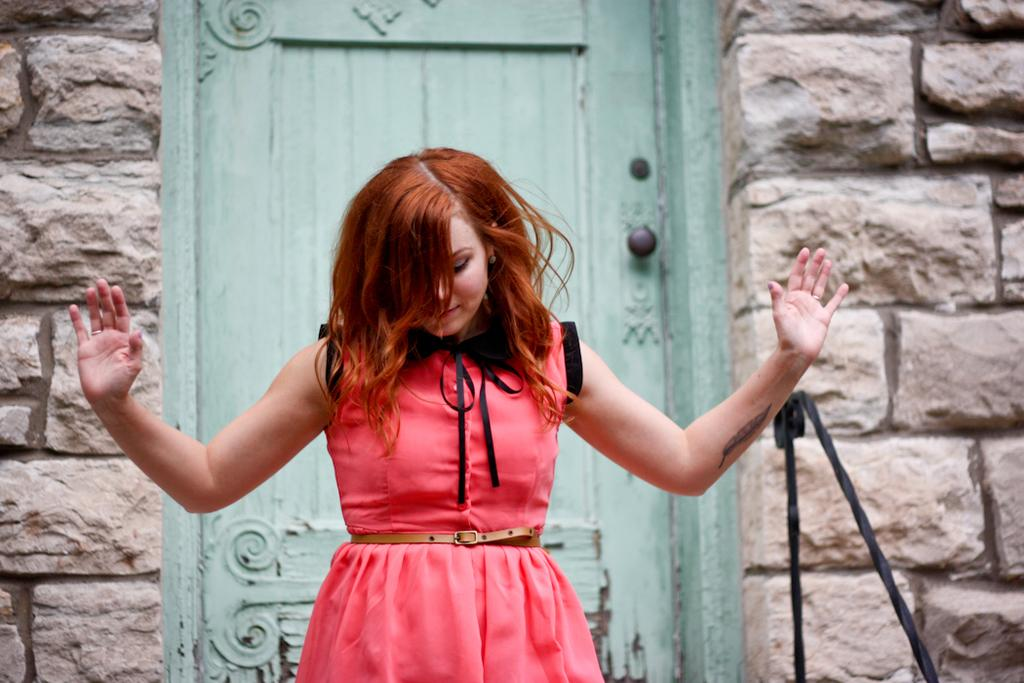What is the main subject of the image? There is a lady standing in the image. Where is the lady positioned in relation to other elements in the image? The lady is standing in front of a door. What type of wall can be seen in the image? There is a stone wall in the image. What other object is present in the image? There is a black color pole in the image. What type of meeting is taking place in the image? There is no meeting taking place in the image; it only shows a lady standing in front of a door. What kind of process is being carried out by the servant in the image? There is no servant present in the image, and therefore no process being carried out. 